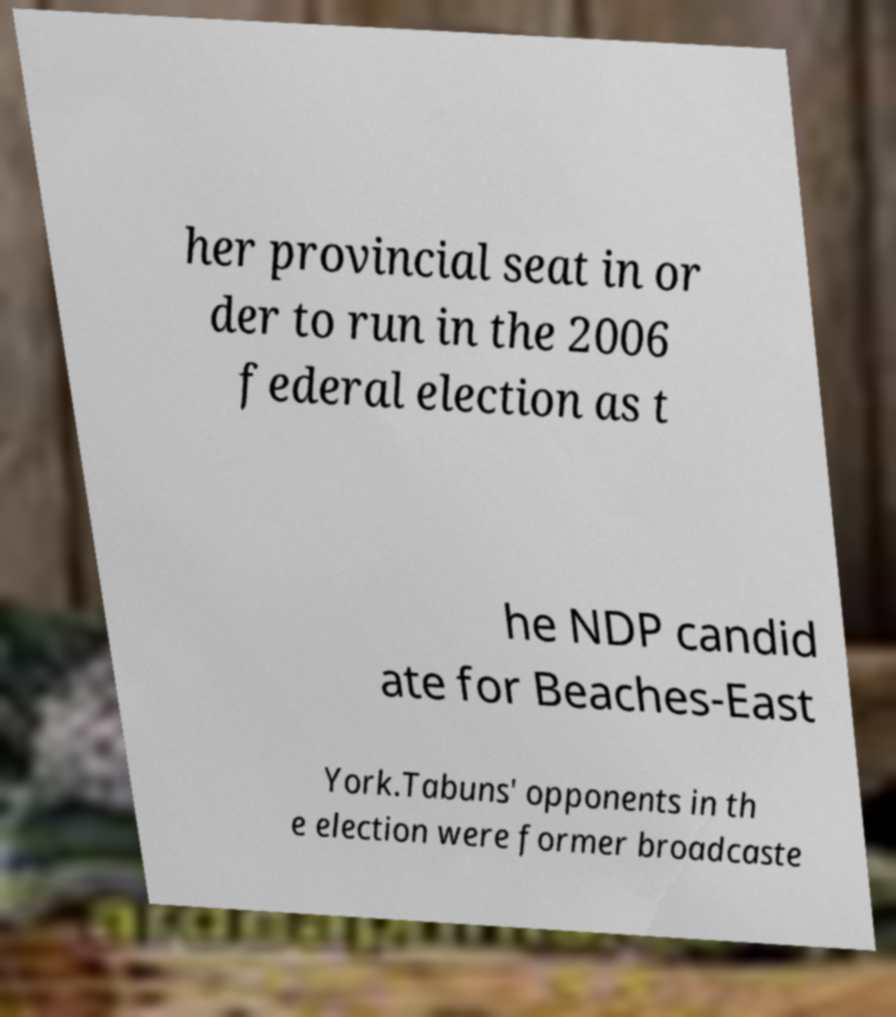Please read and relay the text visible in this image. What does it say? her provincial seat in or der to run in the 2006 federal election as t he NDP candid ate for Beaches-East York.Tabuns' opponents in th e election were former broadcaste 